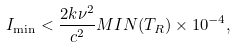Convert formula to latex. <formula><loc_0><loc_0><loc_500><loc_500>I _ { \min } < \frac { 2 k \nu ^ { 2 } } { c ^ { 2 } } M I N ( T _ { R } ) \times 1 0 ^ { - 4 } ,</formula> 